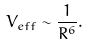Convert formula to latex. <formula><loc_0><loc_0><loc_500><loc_500>V _ { e f f } \sim { \frac { 1 } { R ^ { 6 } } } .</formula> 